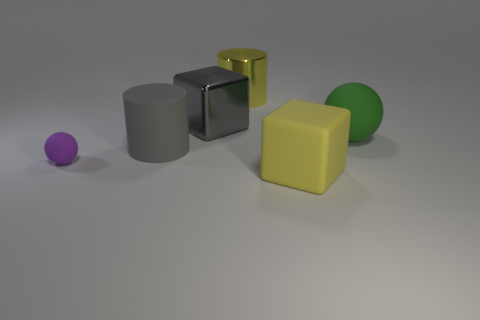Add 1 big cubes. How many objects exist? 7 Subtract all purple spheres. Subtract all red blocks. How many spheres are left? 1 Subtract all cubes. How many objects are left? 4 Add 4 yellow cylinders. How many yellow cylinders exist? 5 Subtract 0 brown cylinders. How many objects are left? 6 Subtract all matte objects. Subtract all gray shiny objects. How many objects are left? 1 Add 5 cylinders. How many cylinders are left? 7 